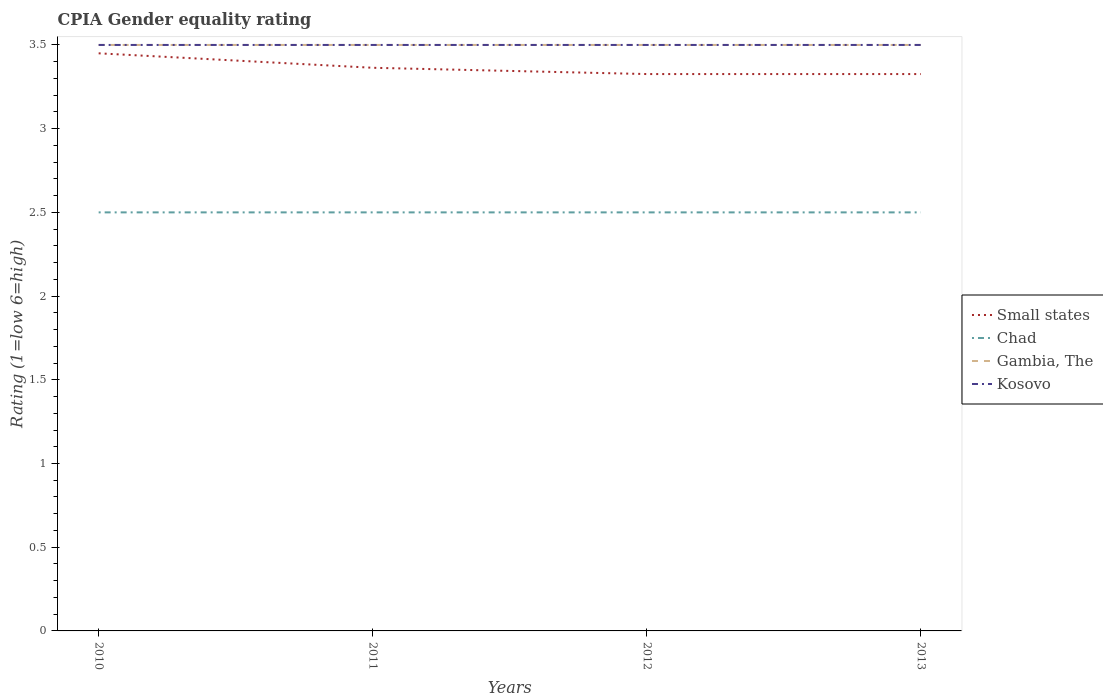How many different coloured lines are there?
Offer a terse response. 4. Is the number of lines equal to the number of legend labels?
Your response must be concise. Yes. What is the total CPIA rating in Small states in the graph?
Keep it short and to the point. 0.12. What is the difference between the highest and the second highest CPIA rating in Gambia, The?
Make the answer very short. 0. How many years are there in the graph?
Your answer should be very brief. 4. What is the difference between two consecutive major ticks on the Y-axis?
Offer a terse response. 0.5. Are the values on the major ticks of Y-axis written in scientific E-notation?
Give a very brief answer. No. Does the graph contain grids?
Keep it short and to the point. No. Where does the legend appear in the graph?
Keep it short and to the point. Center right. What is the title of the graph?
Your answer should be very brief. CPIA Gender equality rating. Does "Samoa" appear as one of the legend labels in the graph?
Make the answer very short. No. What is the label or title of the X-axis?
Give a very brief answer. Years. What is the label or title of the Y-axis?
Ensure brevity in your answer.  Rating (1=low 6=high). What is the Rating (1=low 6=high) in Small states in 2010?
Provide a short and direct response. 3.45. What is the Rating (1=low 6=high) of Gambia, The in 2010?
Your response must be concise. 3.5. What is the Rating (1=low 6=high) of Small states in 2011?
Offer a very short reply. 3.36. What is the Rating (1=low 6=high) of Chad in 2011?
Ensure brevity in your answer.  2.5. What is the Rating (1=low 6=high) of Kosovo in 2011?
Offer a terse response. 3.5. What is the Rating (1=low 6=high) of Small states in 2012?
Make the answer very short. 3.33. What is the Rating (1=low 6=high) of Chad in 2012?
Your answer should be compact. 2.5. What is the Rating (1=low 6=high) in Gambia, The in 2012?
Offer a terse response. 3.5. What is the Rating (1=low 6=high) in Small states in 2013?
Provide a short and direct response. 3.33. What is the Rating (1=low 6=high) of Chad in 2013?
Offer a very short reply. 2.5. What is the Rating (1=low 6=high) of Kosovo in 2013?
Keep it short and to the point. 3.5. Across all years, what is the maximum Rating (1=low 6=high) of Small states?
Offer a terse response. 3.45. Across all years, what is the maximum Rating (1=low 6=high) in Chad?
Your response must be concise. 2.5. Across all years, what is the minimum Rating (1=low 6=high) of Small states?
Your answer should be compact. 3.33. Across all years, what is the minimum Rating (1=low 6=high) of Kosovo?
Provide a short and direct response. 3.5. What is the total Rating (1=low 6=high) in Small states in the graph?
Provide a short and direct response. 13.47. What is the total Rating (1=low 6=high) of Kosovo in the graph?
Your answer should be very brief. 14. What is the difference between the Rating (1=low 6=high) in Small states in 2010 and that in 2011?
Ensure brevity in your answer.  0.09. What is the difference between the Rating (1=low 6=high) of Small states in 2010 and that in 2012?
Your answer should be compact. 0.12. What is the difference between the Rating (1=low 6=high) of Chad in 2010 and that in 2012?
Offer a terse response. 0. What is the difference between the Rating (1=low 6=high) of Gambia, The in 2010 and that in 2012?
Offer a terse response. 0. What is the difference between the Rating (1=low 6=high) of Kosovo in 2010 and that in 2012?
Your answer should be very brief. 0. What is the difference between the Rating (1=low 6=high) in Small states in 2010 and that in 2013?
Provide a short and direct response. 0.12. What is the difference between the Rating (1=low 6=high) of Gambia, The in 2010 and that in 2013?
Provide a succinct answer. 0. What is the difference between the Rating (1=low 6=high) in Kosovo in 2010 and that in 2013?
Provide a short and direct response. 0. What is the difference between the Rating (1=low 6=high) in Small states in 2011 and that in 2012?
Provide a succinct answer. 0.04. What is the difference between the Rating (1=low 6=high) of Chad in 2011 and that in 2012?
Give a very brief answer. 0. What is the difference between the Rating (1=low 6=high) in Small states in 2011 and that in 2013?
Your answer should be compact. 0.04. What is the difference between the Rating (1=low 6=high) in Chad in 2011 and that in 2013?
Make the answer very short. 0. What is the difference between the Rating (1=low 6=high) of Gambia, The in 2011 and that in 2013?
Provide a short and direct response. 0. What is the difference between the Rating (1=low 6=high) in Kosovo in 2011 and that in 2013?
Your answer should be very brief. 0. What is the difference between the Rating (1=low 6=high) of Small states in 2012 and that in 2013?
Offer a terse response. 0. What is the difference between the Rating (1=low 6=high) in Kosovo in 2012 and that in 2013?
Your answer should be very brief. 0. What is the difference between the Rating (1=low 6=high) in Small states in 2010 and the Rating (1=low 6=high) in Gambia, The in 2011?
Your answer should be very brief. -0.05. What is the difference between the Rating (1=low 6=high) of Small states in 2010 and the Rating (1=low 6=high) of Kosovo in 2011?
Keep it short and to the point. -0.05. What is the difference between the Rating (1=low 6=high) of Chad in 2010 and the Rating (1=low 6=high) of Gambia, The in 2011?
Provide a short and direct response. -1. What is the difference between the Rating (1=low 6=high) of Chad in 2010 and the Rating (1=low 6=high) of Kosovo in 2011?
Give a very brief answer. -1. What is the difference between the Rating (1=low 6=high) of Small states in 2010 and the Rating (1=low 6=high) of Chad in 2012?
Your answer should be compact. 0.95. What is the difference between the Rating (1=low 6=high) of Small states in 2010 and the Rating (1=low 6=high) of Gambia, The in 2012?
Make the answer very short. -0.05. What is the difference between the Rating (1=low 6=high) in Chad in 2010 and the Rating (1=low 6=high) in Kosovo in 2012?
Make the answer very short. -1. What is the difference between the Rating (1=low 6=high) in Gambia, The in 2010 and the Rating (1=low 6=high) in Kosovo in 2012?
Your response must be concise. 0. What is the difference between the Rating (1=low 6=high) in Small states in 2010 and the Rating (1=low 6=high) in Chad in 2013?
Provide a short and direct response. 0.95. What is the difference between the Rating (1=low 6=high) of Gambia, The in 2010 and the Rating (1=low 6=high) of Kosovo in 2013?
Keep it short and to the point. 0. What is the difference between the Rating (1=low 6=high) in Small states in 2011 and the Rating (1=low 6=high) in Chad in 2012?
Your answer should be compact. 0.86. What is the difference between the Rating (1=low 6=high) of Small states in 2011 and the Rating (1=low 6=high) of Gambia, The in 2012?
Offer a very short reply. -0.14. What is the difference between the Rating (1=low 6=high) of Small states in 2011 and the Rating (1=low 6=high) of Kosovo in 2012?
Provide a succinct answer. -0.14. What is the difference between the Rating (1=low 6=high) in Small states in 2011 and the Rating (1=low 6=high) in Chad in 2013?
Offer a terse response. 0.86. What is the difference between the Rating (1=low 6=high) in Small states in 2011 and the Rating (1=low 6=high) in Gambia, The in 2013?
Give a very brief answer. -0.14. What is the difference between the Rating (1=low 6=high) of Small states in 2011 and the Rating (1=low 6=high) of Kosovo in 2013?
Give a very brief answer. -0.14. What is the difference between the Rating (1=low 6=high) in Chad in 2011 and the Rating (1=low 6=high) in Gambia, The in 2013?
Your response must be concise. -1. What is the difference between the Rating (1=low 6=high) in Gambia, The in 2011 and the Rating (1=low 6=high) in Kosovo in 2013?
Offer a very short reply. 0. What is the difference between the Rating (1=low 6=high) of Small states in 2012 and the Rating (1=low 6=high) of Chad in 2013?
Your answer should be very brief. 0.83. What is the difference between the Rating (1=low 6=high) of Small states in 2012 and the Rating (1=low 6=high) of Gambia, The in 2013?
Provide a succinct answer. -0.17. What is the difference between the Rating (1=low 6=high) of Small states in 2012 and the Rating (1=low 6=high) of Kosovo in 2013?
Your answer should be very brief. -0.17. What is the difference between the Rating (1=low 6=high) of Chad in 2012 and the Rating (1=low 6=high) of Gambia, The in 2013?
Provide a short and direct response. -1. What is the difference between the Rating (1=low 6=high) in Chad in 2012 and the Rating (1=low 6=high) in Kosovo in 2013?
Offer a very short reply. -1. What is the difference between the Rating (1=low 6=high) of Gambia, The in 2012 and the Rating (1=low 6=high) of Kosovo in 2013?
Your answer should be compact. 0. What is the average Rating (1=low 6=high) in Small states per year?
Offer a very short reply. 3.37. What is the average Rating (1=low 6=high) of Gambia, The per year?
Offer a very short reply. 3.5. In the year 2010, what is the difference between the Rating (1=low 6=high) in Small states and Rating (1=low 6=high) in Gambia, The?
Your answer should be compact. -0.05. In the year 2010, what is the difference between the Rating (1=low 6=high) of Small states and Rating (1=low 6=high) of Kosovo?
Offer a very short reply. -0.05. In the year 2011, what is the difference between the Rating (1=low 6=high) in Small states and Rating (1=low 6=high) in Chad?
Your response must be concise. 0.86. In the year 2011, what is the difference between the Rating (1=low 6=high) in Small states and Rating (1=low 6=high) in Gambia, The?
Provide a short and direct response. -0.14. In the year 2011, what is the difference between the Rating (1=low 6=high) of Small states and Rating (1=low 6=high) of Kosovo?
Ensure brevity in your answer.  -0.14. In the year 2011, what is the difference between the Rating (1=low 6=high) of Chad and Rating (1=low 6=high) of Kosovo?
Provide a succinct answer. -1. In the year 2011, what is the difference between the Rating (1=low 6=high) of Gambia, The and Rating (1=low 6=high) of Kosovo?
Your response must be concise. 0. In the year 2012, what is the difference between the Rating (1=low 6=high) in Small states and Rating (1=low 6=high) in Chad?
Provide a succinct answer. 0.83. In the year 2012, what is the difference between the Rating (1=low 6=high) in Small states and Rating (1=low 6=high) in Gambia, The?
Provide a short and direct response. -0.17. In the year 2012, what is the difference between the Rating (1=low 6=high) in Small states and Rating (1=low 6=high) in Kosovo?
Give a very brief answer. -0.17. In the year 2012, what is the difference between the Rating (1=low 6=high) in Chad and Rating (1=low 6=high) in Gambia, The?
Make the answer very short. -1. In the year 2013, what is the difference between the Rating (1=low 6=high) of Small states and Rating (1=low 6=high) of Chad?
Your answer should be compact. 0.83. In the year 2013, what is the difference between the Rating (1=low 6=high) of Small states and Rating (1=low 6=high) of Gambia, The?
Ensure brevity in your answer.  -0.17. In the year 2013, what is the difference between the Rating (1=low 6=high) of Small states and Rating (1=low 6=high) of Kosovo?
Offer a terse response. -0.17. In the year 2013, what is the difference between the Rating (1=low 6=high) in Chad and Rating (1=low 6=high) in Kosovo?
Offer a terse response. -1. In the year 2013, what is the difference between the Rating (1=low 6=high) in Gambia, The and Rating (1=low 6=high) in Kosovo?
Offer a terse response. 0. What is the ratio of the Rating (1=low 6=high) of Small states in 2010 to that in 2011?
Offer a terse response. 1.03. What is the ratio of the Rating (1=low 6=high) of Chad in 2010 to that in 2011?
Offer a very short reply. 1. What is the ratio of the Rating (1=low 6=high) of Gambia, The in 2010 to that in 2011?
Your response must be concise. 1. What is the ratio of the Rating (1=low 6=high) of Kosovo in 2010 to that in 2011?
Your answer should be compact. 1. What is the ratio of the Rating (1=low 6=high) of Small states in 2010 to that in 2012?
Ensure brevity in your answer.  1.04. What is the ratio of the Rating (1=low 6=high) of Gambia, The in 2010 to that in 2012?
Offer a very short reply. 1. What is the ratio of the Rating (1=low 6=high) of Small states in 2010 to that in 2013?
Offer a terse response. 1.04. What is the ratio of the Rating (1=low 6=high) in Chad in 2010 to that in 2013?
Ensure brevity in your answer.  1. What is the ratio of the Rating (1=low 6=high) in Gambia, The in 2010 to that in 2013?
Provide a succinct answer. 1. What is the ratio of the Rating (1=low 6=high) of Kosovo in 2010 to that in 2013?
Make the answer very short. 1. What is the ratio of the Rating (1=low 6=high) in Small states in 2011 to that in 2012?
Make the answer very short. 1.01. What is the ratio of the Rating (1=low 6=high) of Chad in 2011 to that in 2012?
Make the answer very short. 1. What is the ratio of the Rating (1=low 6=high) of Gambia, The in 2011 to that in 2012?
Provide a short and direct response. 1. What is the ratio of the Rating (1=low 6=high) in Kosovo in 2011 to that in 2012?
Your answer should be compact. 1. What is the ratio of the Rating (1=low 6=high) of Small states in 2011 to that in 2013?
Give a very brief answer. 1.01. What is the ratio of the Rating (1=low 6=high) of Chad in 2011 to that in 2013?
Your answer should be compact. 1. What is the ratio of the Rating (1=low 6=high) of Gambia, The in 2011 to that in 2013?
Your response must be concise. 1. What is the ratio of the Rating (1=low 6=high) in Small states in 2012 to that in 2013?
Your response must be concise. 1. What is the ratio of the Rating (1=low 6=high) of Chad in 2012 to that in 2013?
Your answer should be very brief. 1. What is the ratio of the Rating (1=low 6=high) of Gambia, The in 2012 to that in 2013?
Your answer should be very brief. 1. What is the difference between the highest and the second highest Rating (1=low 6=high) of Small states?
Your answer should be very brief. 0.09. What is the difference between the highest and the lowest Rating (1=low 6=high) in Small states?
Provide a short and direct response. 0.12. What is the difference between the highest and the lowest Rating (1=low 6=high) of Chad?
Ensure brevity in your answer.  0. What is the difference between the highest and the lowest Rating (1=low 6=high) of Gambia, The?
Your answer should be compact. 0. What is the difference between the highest and the lowest Rating (1=low 6=high) of Kosovo?
Offer a terse response. 0. 